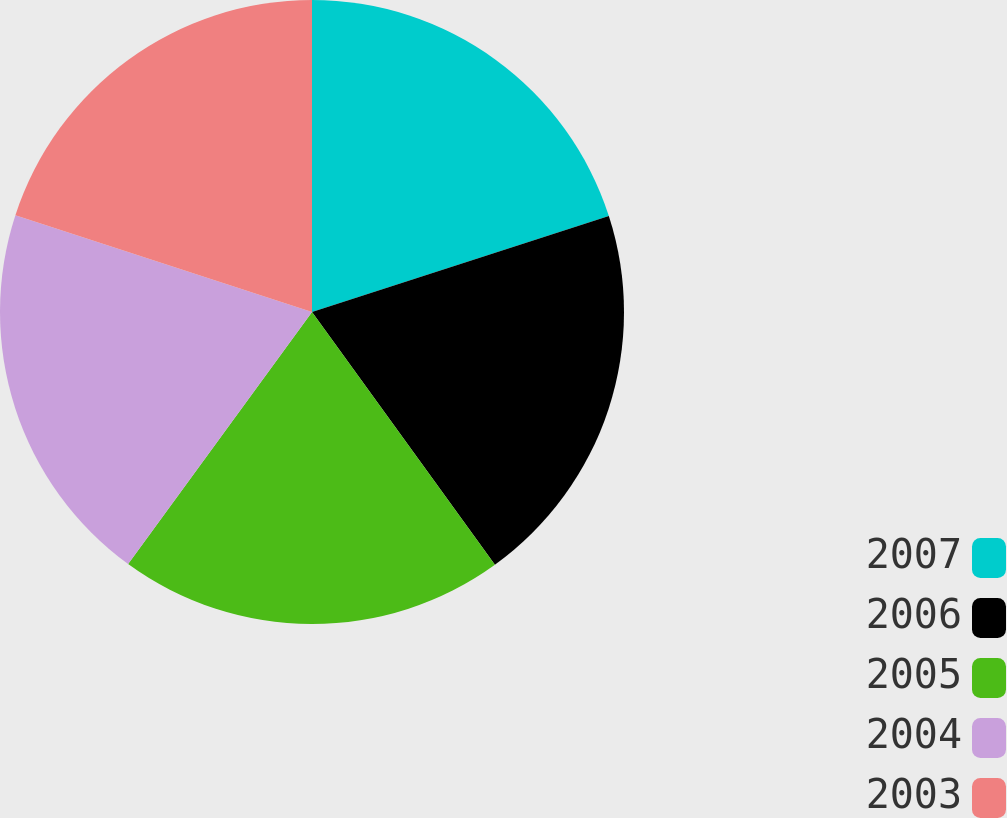Convert chart to OTSL. <chart><loc_0><loc_0><loc_500><loc_500><pie_chart><fcel>2007<fcel>2006<fcel>2005<fcel>2004<fcel>2003<nl><fcel>20.02%<fcel>20.01%<fcel>20.0%<fcel>19.99%<fcel>19.98%<nl></chart> 